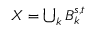<formula> <loc_0><loc_0><loc_500><loc_500>X = \bigcup _ { k } B _ { k } ^ { s , t }</formula> 